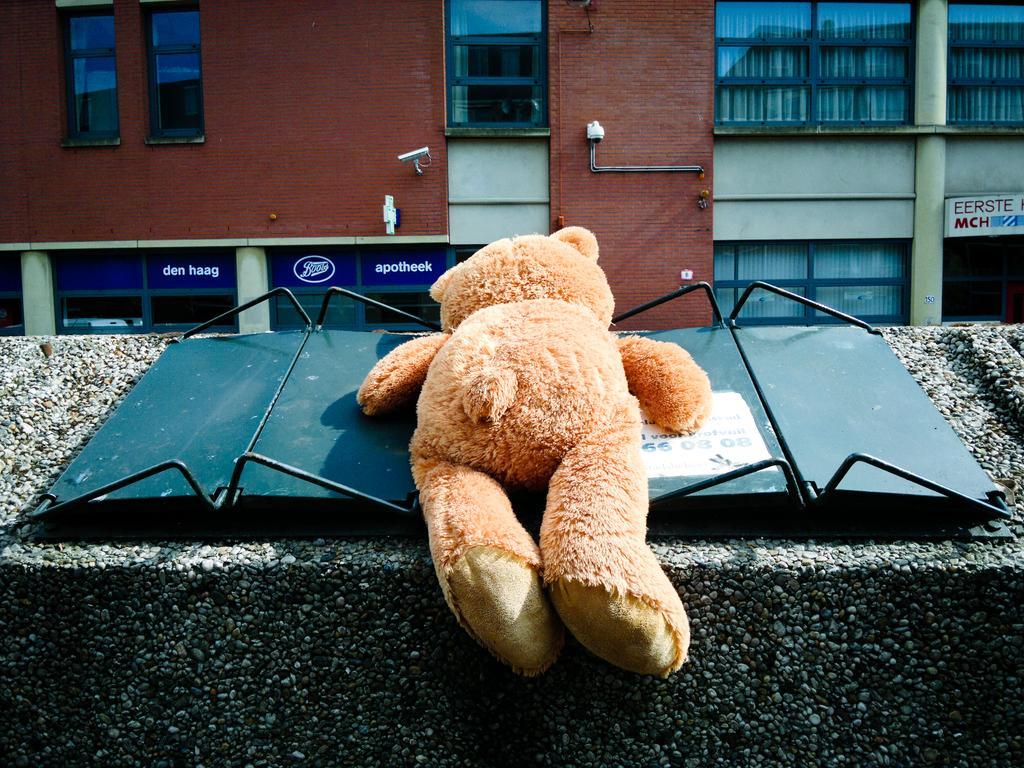Please provide a concise description of this image. Here we can see a toy on a platform. In the background we can see a building, glasses, and boards. 